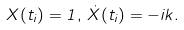<formula> <loc_0><loc_0><loc_500><loc_500>X ( t _ { i } ) = 1 , \, \dot { X } ( t _ { i } ) = - i k .</formula> 